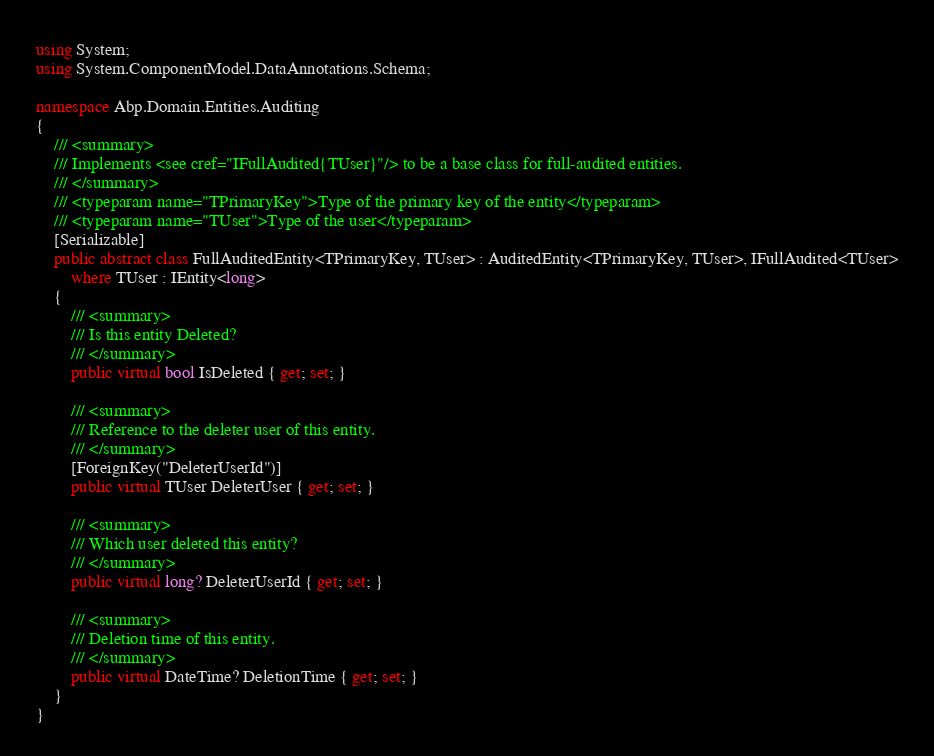Convert code to text. <code><loc_0><loc_0><loc_500><loc_500><_C#_>using System;
using System.ComponentModel.DataAnnotations.Schema;

namespace Abp.Domain.Entities.Auditing
{
    /// <summary>
    /// Implements <see cref="IFullAudited{TUser}"/> to be a base class for full-audited entities.
    /// </summary>
    /// <typeparam name="TPrimaryKey">Type of the primary key of the entity</typeparam>
    /// <typeparam name="TUser">Type of the user</typeparam>
    [Serializable]
    public abstract class FullAuditedEntity<TPrimaryKey, TUser> : AuditedEntity<TPrimaryKey, TUser>, IFullAudited<TUser>
        where TUser : IEntity<long>
    {
        /// <summary>
        /// Is this entity Deleted?
        /// </summary>
        public virtual bool IsDeleted { get; set; }

        /// <summary>
        /// Reference to the deleter user of this entity.
        /// </summary>
        [ForeignKey("DeleterUserId")]
        public virtual TUser DeleterUser { get; set; }

        /// <summary>
        /// Which user deleted this entity?
        /// </summary>
        public virtual long? DeleterUserId { get; set; }

        /// <summary>
        /// Deletion time of this entity.
        /// </summary>
        public virtual DateTime? DeletionTime { get; set; }
    }
}
</code> 